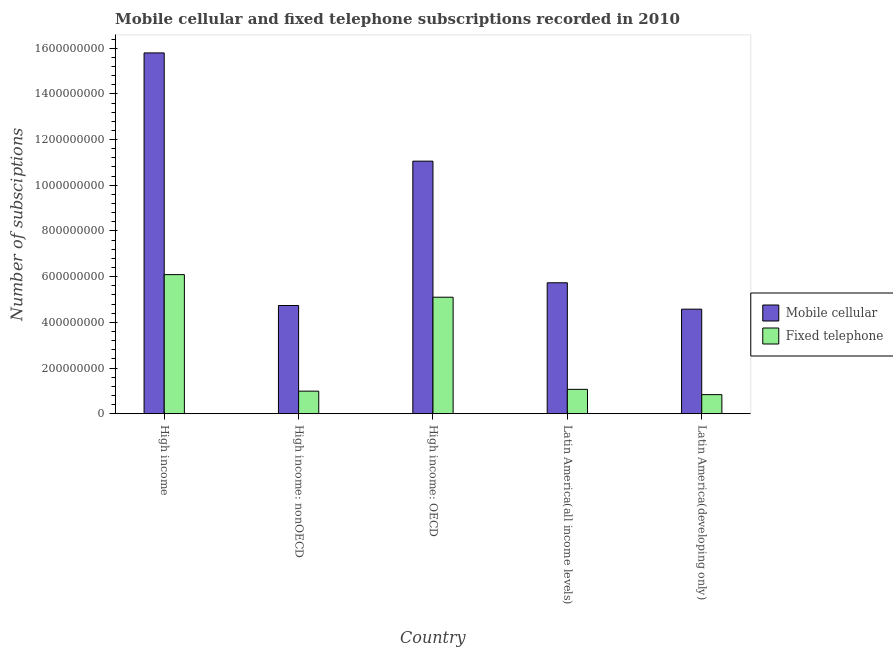How many groups of bars are there?
Provide a short and direct response. 5. Are the number of bars per tick equal to the number of legend labels?
Give a very brief answer. Yes. How many bars are there on the 2nd tick from the left?
Your answer should be compact. 2. What is the label of the 5th group of bars from the left?
Keep it short and to the point. Latin America(developing only). In how many cases, is the number of bars for a given country not equal to the number of legend labels?
Keep it short and to the point. 0. What is the number of mobile cellular subscriptions in Latin America(all income levels)?
Provide a succinct answer. 5.73e+08. Across all countries, what is the maximum number of fixed telephone subscriptions?
Your response must be concise. 6.09e+08. Across all countries, what is the minimum number of mobile cellular subscriptions?
Keep it short and to the point. 4.58e+08. In which country was the number of mobile cellular subscriptions minimum?
Offer a terse response. Latin America(developing only). What is the total number of mobile cellular subscriptions in the graph?
Your response must be concise. 4.19e+09. What is the difference between the number of fixed telephone subscriptions in High income: nonOECD and that in Latin America(all income levels)?
Keep it short and to the point. -7.86e+06. What is the difference between the number of fixed telephone subscriptions in High income: OECD and the number of mobile cellular subscriptions in High income: nonOECD?
Your answer should be compact. 3.64e+07. What is the average number of mobile cellular subscriptions per country?
Provide a succinct answer. 8.38e+08. What is the difference between the number of mobile cellular subscriptions and number of fixed telephone subscriptions in Latin America(developing only)?
Keep it short and to the point. 3.74e+08. What is the ratio of the number of mobile cellular subscriptions in High income to that in High income: OECD?
Offer a very short reply. 1.43. Is the number of mobile cellular subscriptions in High income less than that in Latin America(all income levels)?
Your answer should be very brief. No. Is the difference between the number of fixed telephone subscriptions in High income and Latin America(developing only) greater than the difference between the number of mobile cellular subscriptions in High income and Latin America(developing only)?
Your response must be concise. No. What is the difference between the highest and the second highest number of mobile cellular subscriptions?
Your response must be concise. 4.74e+08. What is the difference between the highest and the lowest number of fixed telephone subscriptions?
Offer a very short reply. 5.25e+08. Is the sum of the number of mobile cellular subscriptions in High income and High income: nonOECD greater than the maximum number of fixed telephone subscriptions across all countries?
Give a very brief answer. Yes. What does the 2nd bar from the left in High income: nonOECD represents?
Keep it short and to the point. Fixed telephone. What does the 2nd bar from the right in High income represents?
Your answer should be compact. Mobile cellular. Are all the bars in the graph horizontal?
Offer a very short reply. No. Where does the legend appear in the graph?
Keep it short and to the point. Center right. How many legend labels are there?
Offer a terse response. 2. How are the legend labels stacked?
Offer a very short reply. Vertical. What is the title of the graph?
Offer a very short reply. Mobile cellular and fixed telephone subscriptions recorded in 2010. Does "Males" appear as one of the legend labels in the graph?
Your answer should be very brief. No. What is the label or title of the X-axis?
Your answer should be very brief. Country. What is the label or title of the Y-axis?
Provide a succinct answer. Number of subsciptions. What is the Number of subsciptions in Mobile cellular in High income?
Your answer should be very brief. 1.58e+09. What is the Number of subsciptions in Fixed telephone in High income?
Make the answer very short. 6.09e+08. What is the Number of subsciptions of Mobile cellular in High income: nonOECD?
Provide a succinct answer. 4.74e+08. What is the Number of subsciptions in Fixed telephone in High income: nonOECD?
Ensure brevity in your answer.  9.89e+07. What is the Number of subsciptions in Mobile cellular in High income: OECD?
Offer a very short reply. 1.11e+09. What is the Number of subsciptions of Fixed telephone in High income: OECD?
Your answer should be very brief. 5.10e+08. What is the Number of subsciptions in Mobile cellular in Latin America(all income levels)?
Your answer should be very brief. 5.73e+08. What is the Number of subsciptions in Fixed telephone in Latin America(all income levels)?
Keep it short and to the point. 1.07e+08. What is the Number of subsciptions in Mobile cellular in Latin America(developing only)?
Ensure brevity in your answer.  4.58e+08. What is the Number of subsciptions in Fixed telephone in Latin America(developing only)?
Provide a short and direct response. 8.36e+07. Across all countries, what is the maximum Number of subsciptions in Mobile cellular?
Provide a succinct answer. 1.58e+09. Across all countries, what is the maximum Number of subsciptions of Fixed telephone?
Offer a terse response. 6.09e+08. Across all countries, what is the minimum Number of subsciptions of Mobile cellular?
Your response must be concise. 4.58e+08. Across all countries, what is the minimum Number of subsciptions of Fixed telephone?
Offer a very short reply. 8.36e+07. What is the total Number of subsciptions in Mobile cellular in the graph?
Your response must be concise. 4.19e+09. What is the total Number of subsciptions in Fixed telephone in the graph?
Your response must be concise. 1.41e+09. What is the difference between the Number of subsciptions of Mobile cellular in High income and that in High income: nonOECD?
Give a very brief answer. 1.11e+09. What is the difference between the Number of subsciptions of Fixed telephone in High income and that in High income: nonOECD?
Offer a terse response. 5.10e+08. What is the difference between the Number of subsciptions in Mobile cellular in High income and that in High income: OECD?
Make the answer very short. 4.74e+08. What is the difference between the Number of subsciptions in Fixed telephone in High income and that in High income: OECD?
Provide a succinct answer. 9.89e+07. What is the difference between the Number of subsciptions of Mobile cellular in High income and that in Latin America(all income levels)?
Your answer should be compact. 1.01e+09. What is the difference between the Number of subsciptions of Fixed telephone in High income and that in Latin America(all income levels)?
Your response must be concise. 5.02e+08. What is the difference between the Number of subsciptions of Mobile cellular in High income and that in Latin America(developing only)?
Make the answer very short. 1.12e+09. What is the difference between the Number of subsciptions of Fixed telephone in High income and that in Latin America(developing only)?
Ensure brevity in your answer.  5.25e+08. What is the difference between the Number of subsciptions of Mobile cellular in High income: nonOECD and that in High income: OECD?
Your answer should be very brief. -6.32e+08. What is the difference between the Number of subsciptions of Fixed telephone in High income: nonOECD and that in High income: OECD?
Ensure brevity in your answer.  -4.11e+08. What is the difference between the Number of subsciptions of Mobile cellular in High income: nonOECD and that in Latin America(all income levels)?
Offer a very short reply. -9.95e+07. What is the difference between the Number of subsciptions of Fixed telephone in High income: nonOECD and that in Latin America(all income levels)?
Ensure brevity in your answer.  -7.86e+06. What is the difference between the Number of subsciptions of Mobile cellular in High income: nonOECD and that in Latin America(developing only)?
Offer a very short reply. 1.60e+07. What is the difference between the Number of subsciptions in Fixed telephone in High income: nonOECD and that in Latin America(developing only)?
Offer a terse response. 1.53e+07. What is the difference between the Number of subsciptions of Mobile cellular in High income: OECD and that in Latin America(all income levels)?
Your answer should be compact. 5.32e+08. What is the difference between the Number of subsciptions of Fixed telephone in High income: OECD and that in Latin America(all income levels)?
Offer a terse response. 4.03e+08. What is the difference between the Number of subsciptions in Mobile cellular in High income: OECD and that in Latin America(developing only)?
Your answer should be compact. 6.48e+08. What is the difference between the Number of subsciptions of Fixed telephone in High income: OECD and that in Latin America(developing only)?
Your answer should be compact. 4.26e+08. What is the difference between the Number of subsciptions in Mobile cellular in Latin America(all income levels) and that in Latin America(developing only)?
Make the answer very short. 1.16e+08. What is the difference between the Number of subsciptions of Fixed telephone in Latin America(all income levels) and that in Latin America(developing only)?
Ensure brevity in your answer.  2.32e+07. What is the difference between the Number of subsciptions of Mobile cellular in High income and the Number of subsciptions of Fixed telephone in High income: nonOECD?
Give a very brief answer. 1.48e+09. What is the difference between the Number of subsciptions of Mobile cellular in High income and the Number of subsciptions of Fixed telephone in High income: OECD?
Offer a very short reply. 1.07e+09. What is the difference between the Number of subsciptions of Mobile cellular in High income and the Number of subsciptions of Fixed telephone in Latin America(all income levels)?
Your answer should be compact. 1.47e+09. What is the difference between the Number of subsciptions of Mobile cellular in High income and the Number of subsciptions of Fixed telephone in Latin America(developing only)?
Keep it short and to the point. 1.50e+09. What is the difference between the Number of subsciptions of Mobile cellular in High income: nonOECD and the Number of subsciptions of Fixed telephone in High income: OECD?
Your answer should be compact. -3.64e+07. What is the difference between the Number of subsciptions in Mobile cellular in High income: nonOECD and the Number of subsciptions in Fixed telephone in Latin America(all income levels)?
Ensure brevity in your answer.  3.67e+08. What is the difference between the Number of subsciptions of Mobile cellular in High income: nonOECD and the Number of subsciptions of Fixed telephone in Latin America(developing only)?
Provide a succinct answer. 3.90e+08. What is the difference between the Number of subsciptions in Mobile cellular in High income: OECD and the Number of subsciptions in Fixed telephone in Latin America(all income levels)?
Provide a succinct answer. 9.99e+08. What is the difference between the Number of subsciptions of Mobile cellular in High income: OECD and the Number of subsciptions of Fixed telephone in Latin America(developing only)?
Your answer should be compact. 1.02e+09. What is the difference between the Number of subsciptions in Mobile cellular in Latin America(all income levels) and the Number of subsciptions in Fixed telephone in Latin America(developing only)?
Provide a succinct answer. 4.90e+08. What is the average Number of subsciptions of Mobile cellular per country?
Your answer should be compact. 8.38e+08. What is the average Number of subsciptions in Fixed telephone per country?
Your answer should be compact. 2.82e+08. What is the difference between the Number of subsciptions of Mobile cellular and Number of subsciptions of Fixed telephone in High income?
Give a very brief answer. 9.70e+08. What is the difference between the Number of subsciptions of Mobile cellular and Number of subsciptions of Fixed telephone in High income: nonOECD?
Make the answer very short. 3.75e+08. What is the difference between the Number of subsciptions of Mobile cellular and Number of subsciptions of Fixed telephone in High income: OECD?
Ensure brevity in your answer.  5.96e+08. What is the difference between the Number of subsciptions in Mobile cellular and Number of subsciptions in Fixed telephone in Latin America(all income levels)?
Offer a terse response. 4.67e+08. What is the difference between the Number of subsciptions in Mobile cellular and Number of subsciptions in Fixed telephone in Latin America(developing only)?
Offer a terse response. 3.74e+08. What is the ratio of the Number of subsciptions of Mobile cellular in High income to that in High income: nonOECD?
Your answer should be very brief. 3.33. What is the ratio of the Number of subsciptions of Fixed telephone in High income to that in High income: nonOECD?
Ensure brevity in your answer.  6.16. What is the ratio of the Number of subsciptions of Mobile cellular in High income to that in High income: OECD?
Keep it short and to the point. 1.43. What is the ratio of the Number of subsciptions of Fixed telephone in High income to that in High income: OECD?
Ensure brevity in your answer.  1.19. What is the ratio of the Number of subsciptions in Mobile cellular in High income to that in Latin America(all income levels)?
Give a very brief answer. 2.76. What is the ratio of the Number of subsciptions in Fixed telephone in High income to that in Latin America(all income levels)?
Keep it short and to the point. 5.7. What is the ratio of the Number of subsciptions in Mobile cellular in High income to that in Latin America(developing only)?
Offer a terse response. 3.45. What is the ratio of the Number of subsciptions in Fixed telephone in High income to that in Latin America(developing only)?
Your answer should be compact. 7.28. What is the ratio of the Number of subsciptions in Mobile cellular in High income: nonOECD to that in High income: OECD?
Your answer should be compact. 0.43. What is the ratio of the Number of subsciptions of Fixed telephone in High income: nonOECD to that in High income: OECD?
Give a very brief answer. 0.19. What is the ratio of the Number of subsciptions in Mobile cellular in High income: nonOECD to that in Latin America(all income levels)?
Give a very brief answer. 0.83. What is the ratio of the Number of subsciptions in Fixed telephone in High income: nonOECD to that in Latin America(all income levels)?
Your answer should be very brief. 0.93. What is the ratio of the Number of subsciptions of Mobile cellular in High income: nonOECD to that in Latin America(developing only)?
Provide a succinct answer. 1.03. What is the ratio of the Number of subsciptions of Fixed telephone in High income: nonOECD to that in Latin America(developing only)?
Offer a terse response. 1.18. What is the ratio of the Number of subsciptions of Mobile cellular in High income: OECD to that in Latin America(all income levels)?
Your response must be concise. 1.93. What is the ratio of the Number of subsciptions of Fixed telephone in High income: OECD to that in Latin America(all income levels)?
Offer a very short reply. 4.78. What is the ratio of the Number of subsciptions of Mobile cellular in High income: OECD to that in Latin America(developing only)?
Keep it short and to the point. 2.42. What is the ratio of the Number of subsciptions in Fixed telephone in High income: OECD to that in Latin America(developing only)?
Offer a very short reply. 6.1. What is the ratio of the Number of subsciptions of Mobile cellular in Latin America(all income levels) to that in Latin America(developing only)?
Give a very brief answer. 1.25. What is the ratio of the Number of subsciptions of Fixed telephone in Latin America(all income levels) to that in Latin America(developing only)?
Provide a short and direct response. 1.28. What is the difference between the highest and the second highest Number of subsciptions of Mobile cellular?
Your response must be concise. 4.74e+08. What is the difference between the highest and the second highest Number of subsciptions in Fixed telephone?
Offer a terse response. 9.89e+07. What is the difference between the highest and the lowest Number of subsciptions of Mobile cellular?
Keep it short and to the point. 1.12e+09. What is the difference between the highest and the lowest Number of subsciptions of Fixed telephone?
Your response must be concise. 5.25e+08. 